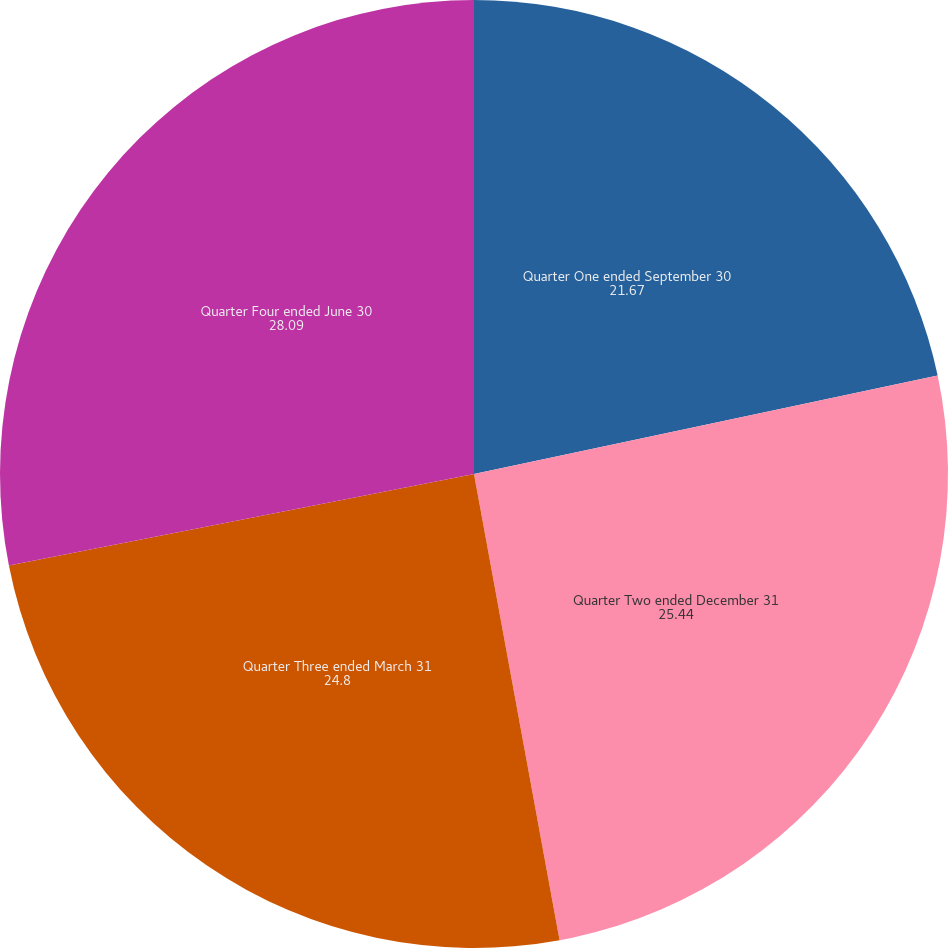Convert chart to OTSL. <chart><loc_0><loc_0><loc_500><loc_500><pie_chart><fcel>Quarter One ended September 30<fcel>Quarter Two ended December 31<fcel>Quarter Three ended March 31<fcel>Quarter Four ended June 30<nl><fcel>21.67%<fcel>25.44%<fcel>24.8%<fcel>28.09%<nl></chart> 